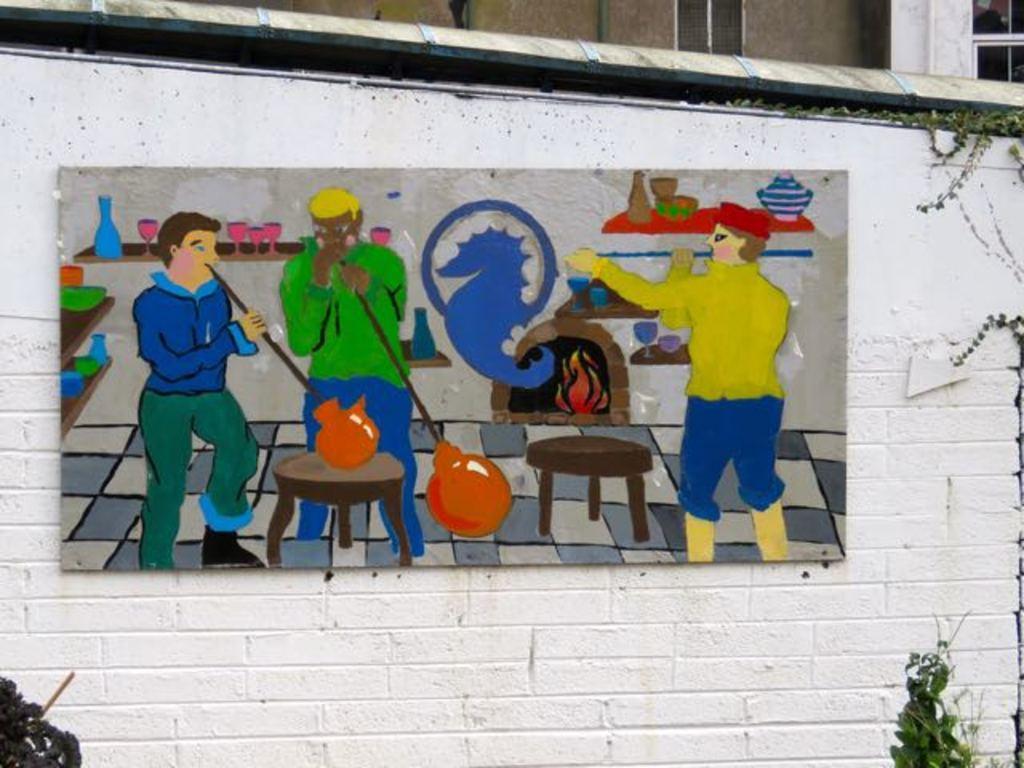How would you summarize this image in a sentence or two? In the image there is a white wall with painting in the middle with plants on either side of it and behind it seems to be a building. 